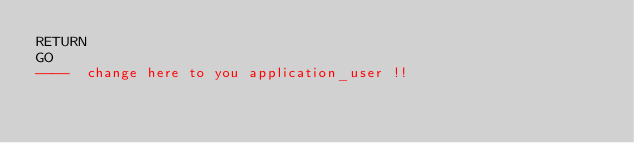<code> <loc_0><loc_0><loc_500><loc_500><_SQL_>RETURN
GO
----  change here to you application_user !!</code> 